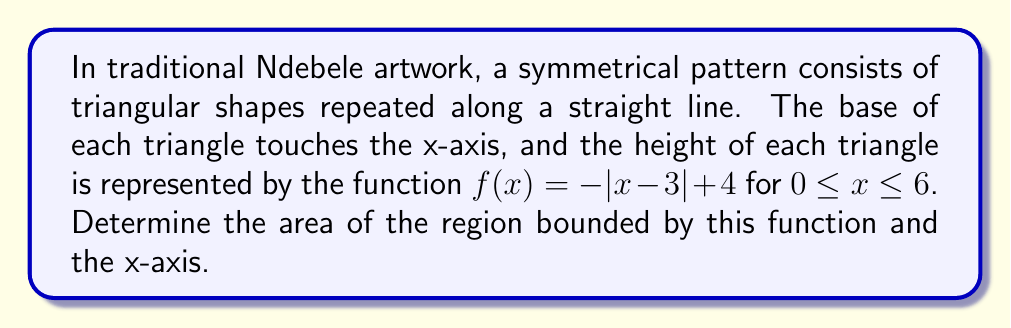What is the answer to this math problem? Let's approach this step-by-step:

1) The function $f(x) = -|x - 3| + 4$ represents an isosceles triangle with its peak at (3, 4).

2) The triangle intersects the x-axis at two points. To find these, set $f(x) = 0$:

   $-|x - 3| + 4 = 0$
   $|x - 3| = 4$

   Solving this gives us $x = -1$ and $x = 7$. However, our domain is restricted to $0 \leq x \leq 6$.

3) So, our triangle intersects the x-axis at $x = 0$ and $x = 6$.

4) The area of this region can be calculated using the integral:

   $A = \int_0^6 f(x) dx$

5) However, due to the absolute value function, we need to split this integral at $x = 3$:

   $A = \int_0^3 (-x + 3 + 4) dx + \int_3^6 (x - 3 + 4) dx$

6) Simplifying:

   $A = \int_0^3 (-x + 7) dx + \int_3^6 (x + 1) dx$

7) Evaluating the integrals:

   $A = [-\frac{1}{2}x^2 + 7x]_0^3 + [\frac{1}{2}x^2 + x]_3^6$

8) Calculating:

   $A = (-\frac{9}{2} + 21) + (\frac{36}{2} + 6 - \frac{9}{2} - 3)$
   $A = \frac{33}{2} + 15 = \frac{63}{2} = 31.5$

Therefore, the area of the region is 31.5 square units.
Answer: 31.5 square units 